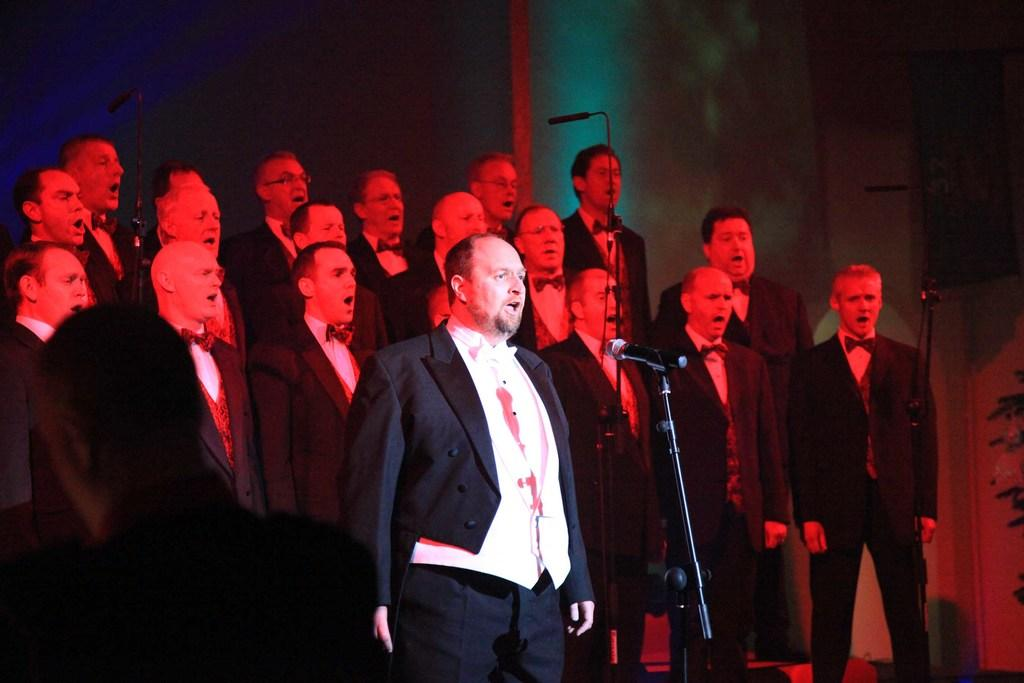What are the people in the image doing? The people in the image are singing. What objects are in front of the people? There are stands and microphones in front of the people. What can be seen in the background of the image? There is a wall visible in the background of the image. What type of tax is being discussed by the people singing in the image? There is no indication in the image that the people singing are discussing any type of tax. 